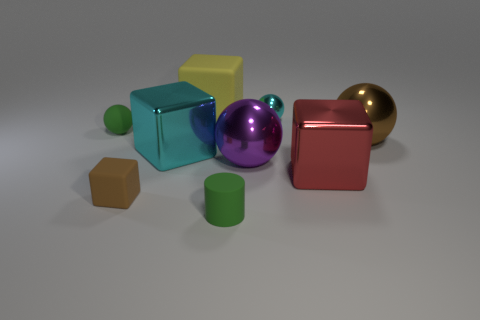Subtract all small blocks. How many blocks are left? 3 Subtract all brown cubes. How many cubes are left? 3 Subtract 2 spheres. How many spheres are left? 2 Subtract all purple spheres. How many cyan cubes are left? 1 Subtract all cylinders. How many objects are left? 8 Subtract all purple spheres. Subtract all cyan metal objects. How many objects are left? 6 Add 5 brown matte things. How many brown matte things are left? 6 Add 9 small red objects. How many small red objects exist? 9 Subtract 0 red spheres. How many objects are left? 9 Subtract all green spheres. Subtract all red cubes. How many spheres are left? 3 